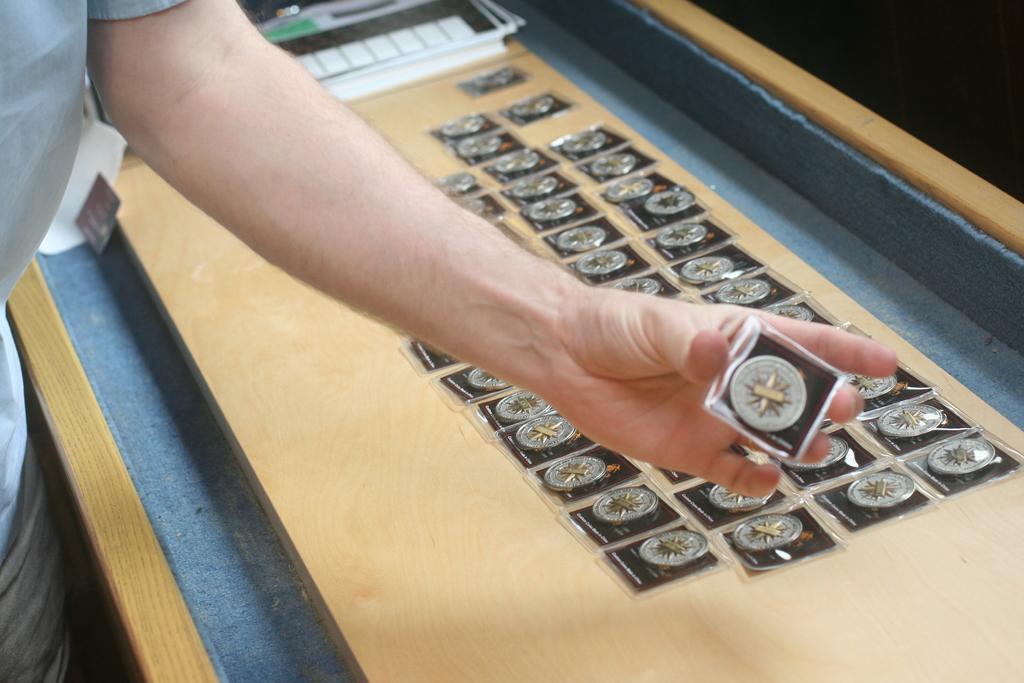In one or two sentences, can you explain what this image depicts? We can see a person holding something in the hand. In the background there is a wooden table with some items on that. 